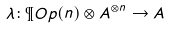<formula> <loc_0><loc_0><loc_500><loc_500>\lambda \colon \P O p ( n ) \otimes A ^ { \otimes n } \rightarrow A</formula> 